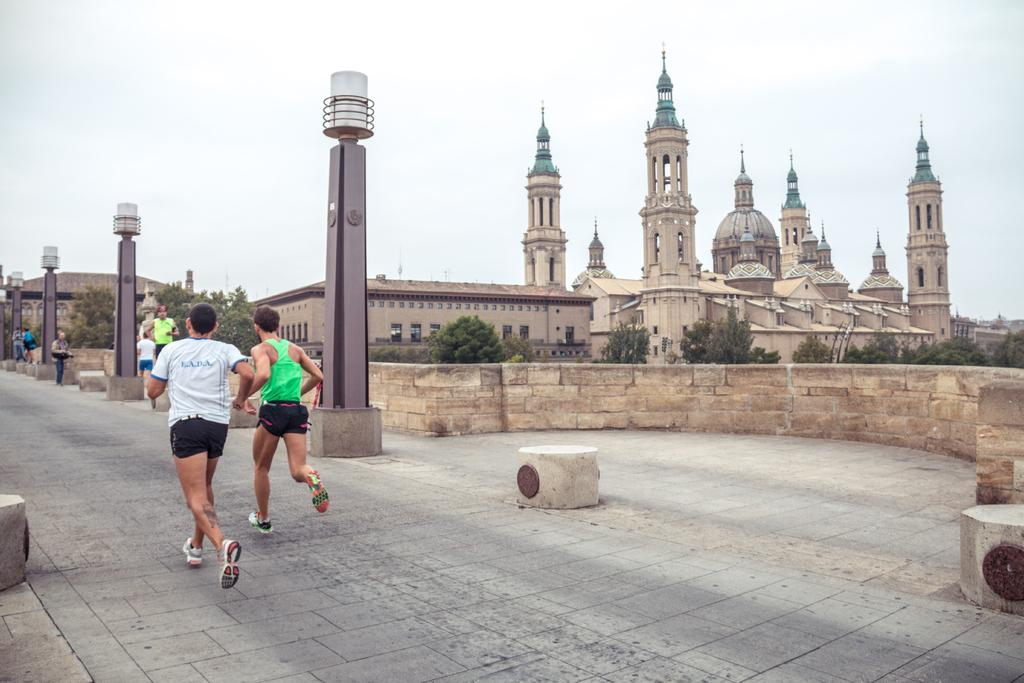What are the two men in the image doing? The two men in the image are running on the road. What can be seen in the background of the image? Trees, a wall, and a building are visible in the background of the image. What else is present on the road in the image? There are persons standing on the road and street poles are present. What is used to illuminate the road at night? Street lights are visible in the image. What is visible at the top of the image? The sky is visible in the image. Where is the cub hiding in the image? There is no cub present in the image. What type of drawer can be seen in the image? There are no drawers present in the image. 